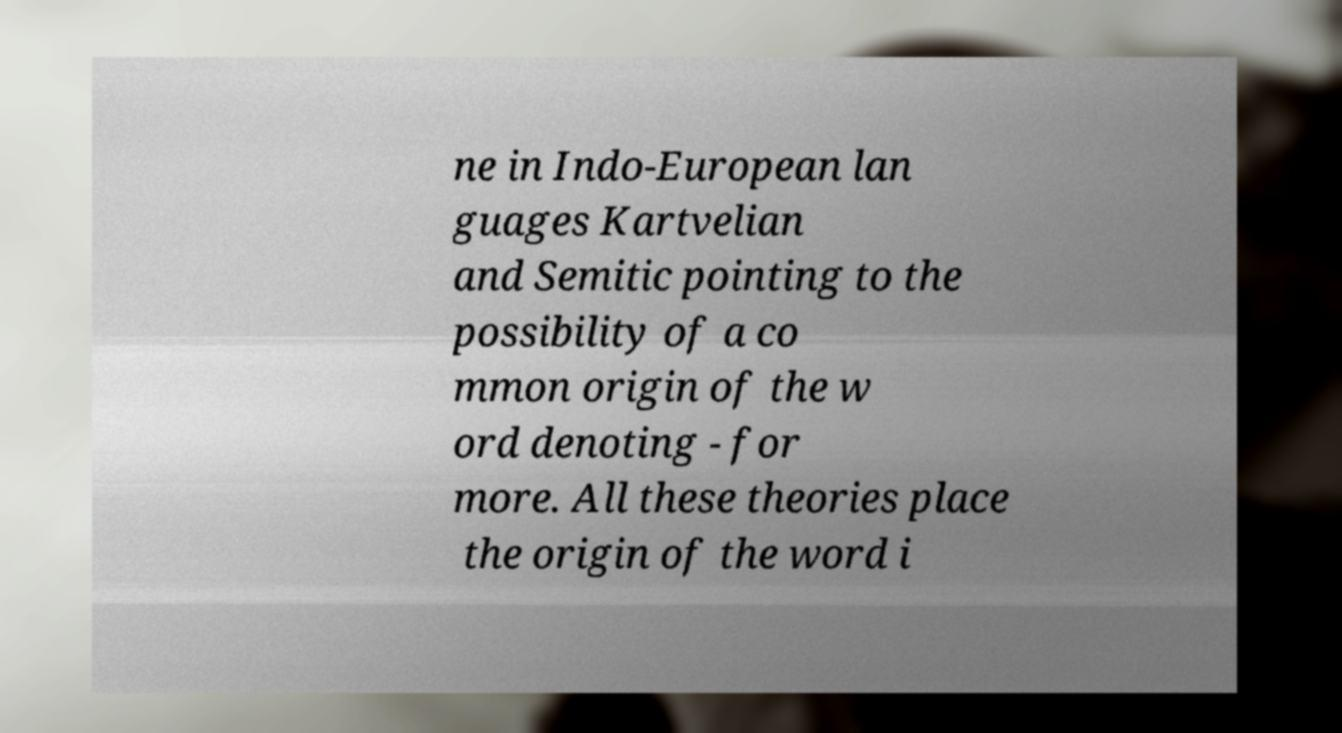There's text embedded in this image that I need extracted. Can you transcribe it verbatim? ne in Indo-European lan guages Kartvelian and Semitic pointing to the possibility of a co mmon origin of the w ord denoting - for more. All these theories place the origin of the word i 